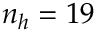<formula> <loc_0><loc_0><loc_500><loc_500>n _ { h } = 1 9</formula> 